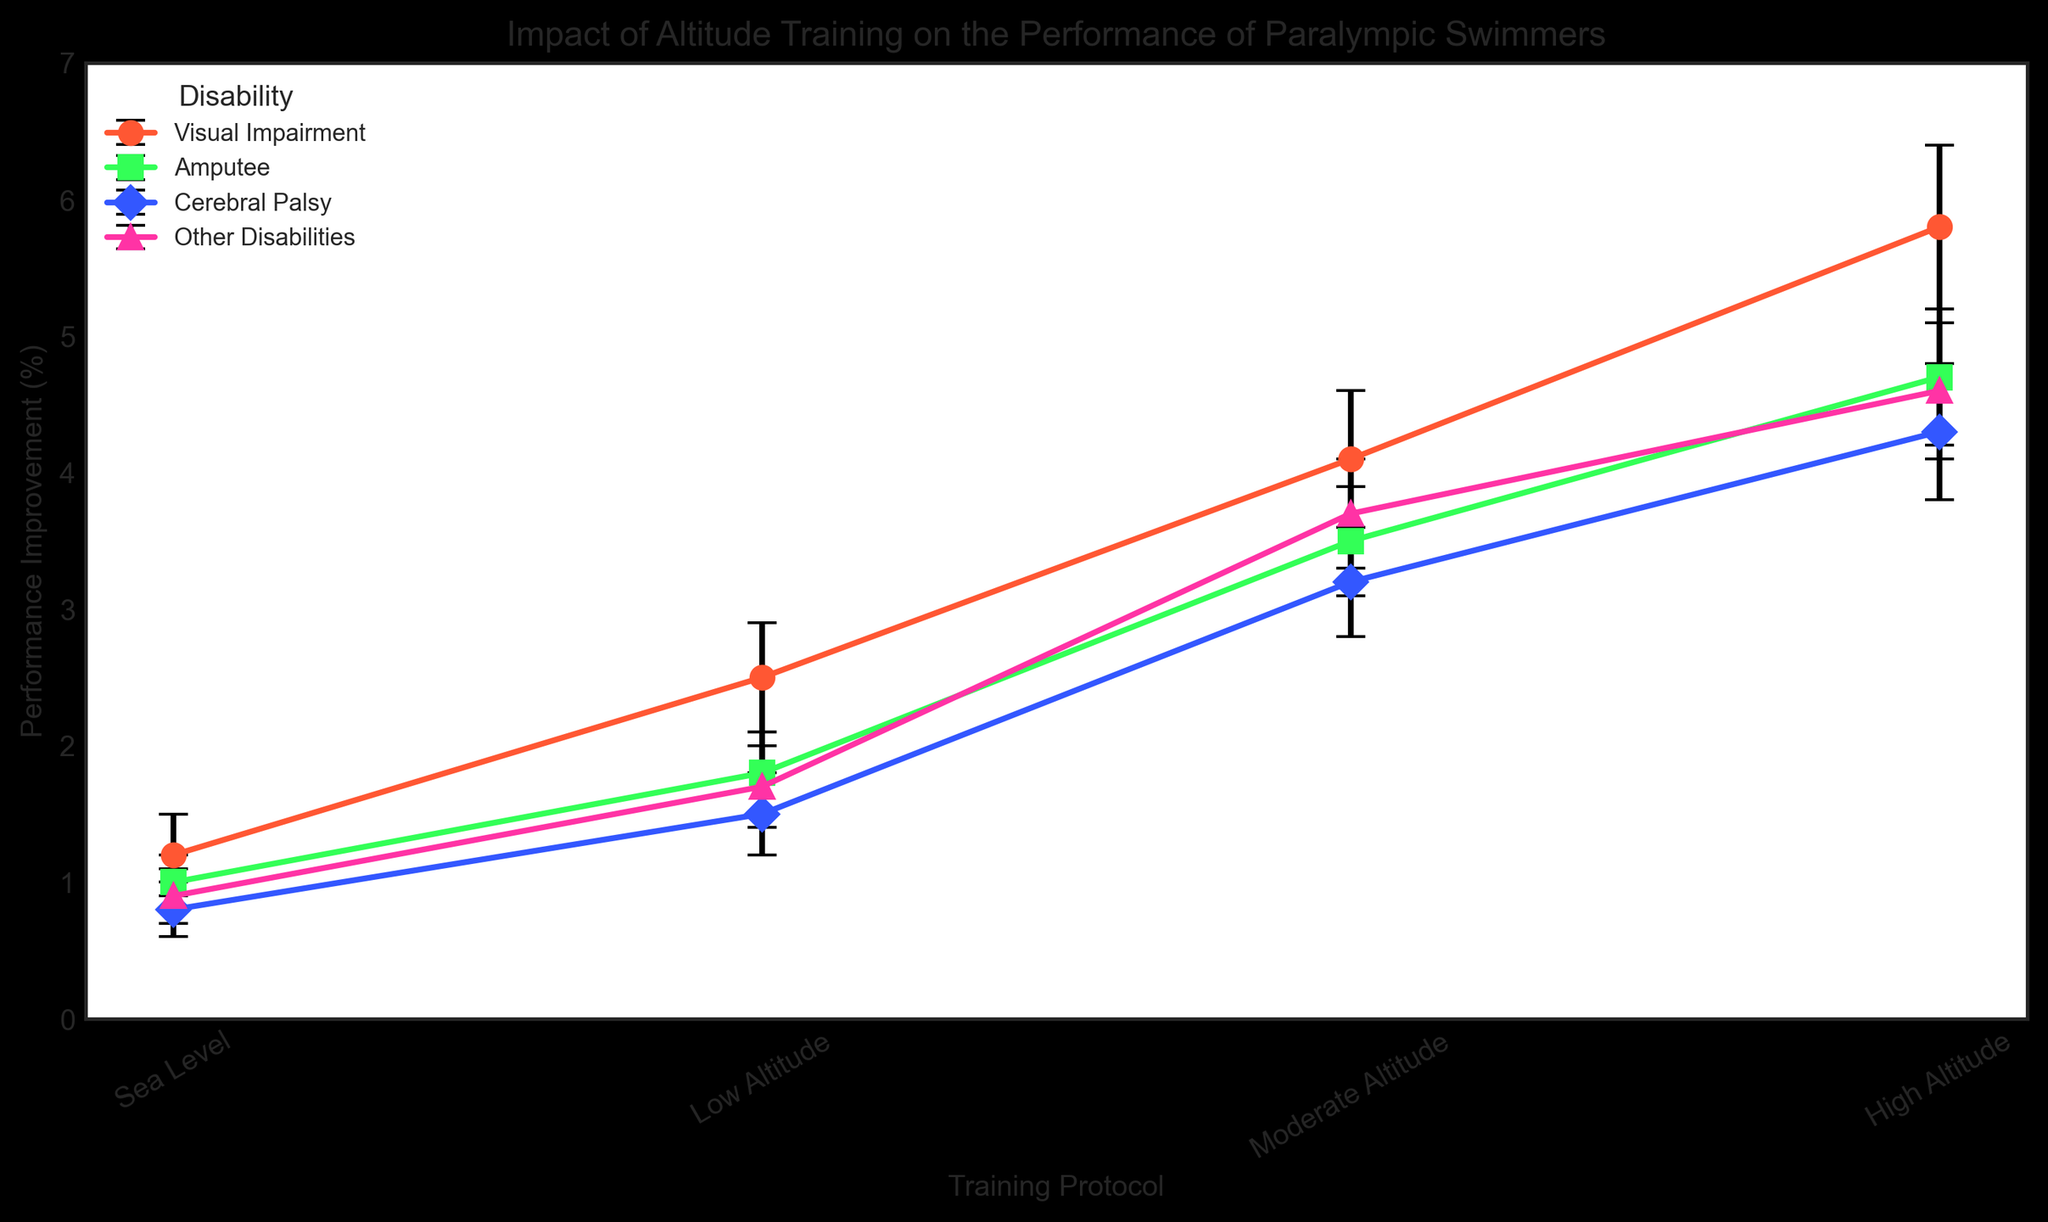What is the highest performance improvement observed for swimmers with Visual Impairment, and under which training protocol? The highest performance improvement for swimmers with Visual Impairment is shown by the tallest data point in the "Visual Impairment" line, which is at the "High Altitude" training protocol.
Answer: 5.8%, High Altitude What is the difference in performance improvement between "High Altitude" and "Moderate Altitude" training protocols for Amputee swimmers? For Amputee swimmers, the performance improvement at "High Altitude" is 4.7%, and at "Moderate Altitude" it is 3.5%. Subtracting these gives 4.7% - 3.5% = 1.2%.
Answer: 1.2% Which disability group shows the least performance improvement at "Low Altitude" training protocol? The least performance improvement at "Low Altitude" is the data point with the shortest vertical measurement for a respective group, identified as the "Cerebral Palsy" group with 1.5%.
Answer: Cerebral Palsy Comparing the performance improvements at "Sea Level" across all disabilities, which group shows the most improvement? The "Sea Level" data points indicate that the "Visual Impairment" group shows the highest improvement among all disabilities with 1.2%.
Answer: Visual Impairment How much greater is the performance improvement for swimmers with Cerebral Palsy at "Moderate Altitude" compared to "Sea Level"? For swimmers with Cerebral Palsy, the performance improvement at "Moderate Altitude" is 3.2%, and at "Sea Level" it is 0.8%. The difference is 3.2% - 0.8% = 2.4%.
Answer: 2.4% What pattern is observed about the error size across different training protocols for swimmers with Other Disabilities? The error size for swimmers with Other Disabilities increases progressively with each higher training altitude: 0.2 at Sea Level, 0.3 at Low Altitude, 0.4 at Moderate Altitude, and 0.5 at High Altitude.
Answer: Error size increases with altitude 